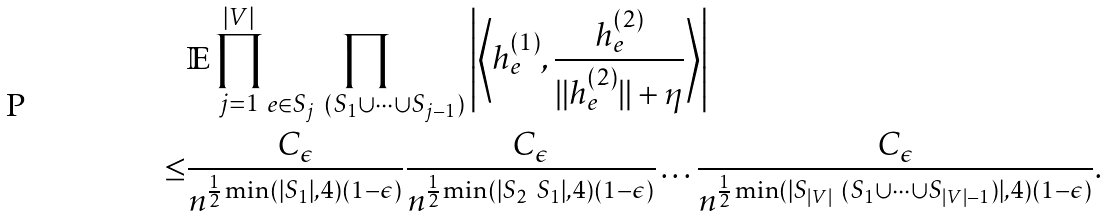Convert formula to latex. <formula><loc_0><loc_0><loc_500><loc_500>& \mathbb { E } \prod _ { j = 1 } ^ { | V | } \prod _ { e \in S _ { j } \ ( S _ { 1 } \cup \dots \cup S _ { j - 1 } ) } \left | \left \langle h _ { e } ^ { ( 1 ) } , \frac { h _ { e } ^ { ( 2 ) } } { \| h _ { e } ^ { ( 2 ) } \| + \eta } \right \rangle \right | \\ \leq & \frac { C _ { \epsilon } } { n ^ { \frac { 1 } { 2 } \min ( | S _ { 1 } | , 4 ) ( 1 - \epsilon ) } } \frac { C _ { \epsilon } } { n ^ { \frac { 1 } { 2 } \min ( | S _ { 2 } \ S _ { 1 } | , 4 ) ( 1 - \epsilon ) } } \dots \frac { C _ { \epsilon } } { n ^ { \frac { 1 } { 2 } \min ( | S _ { | V | } \ ( S _ { 1 } \cup \dots \cup S _ { | V | - 1 } ) | , 4 ) ( 1 - \epsilon ) } } .</formula> 